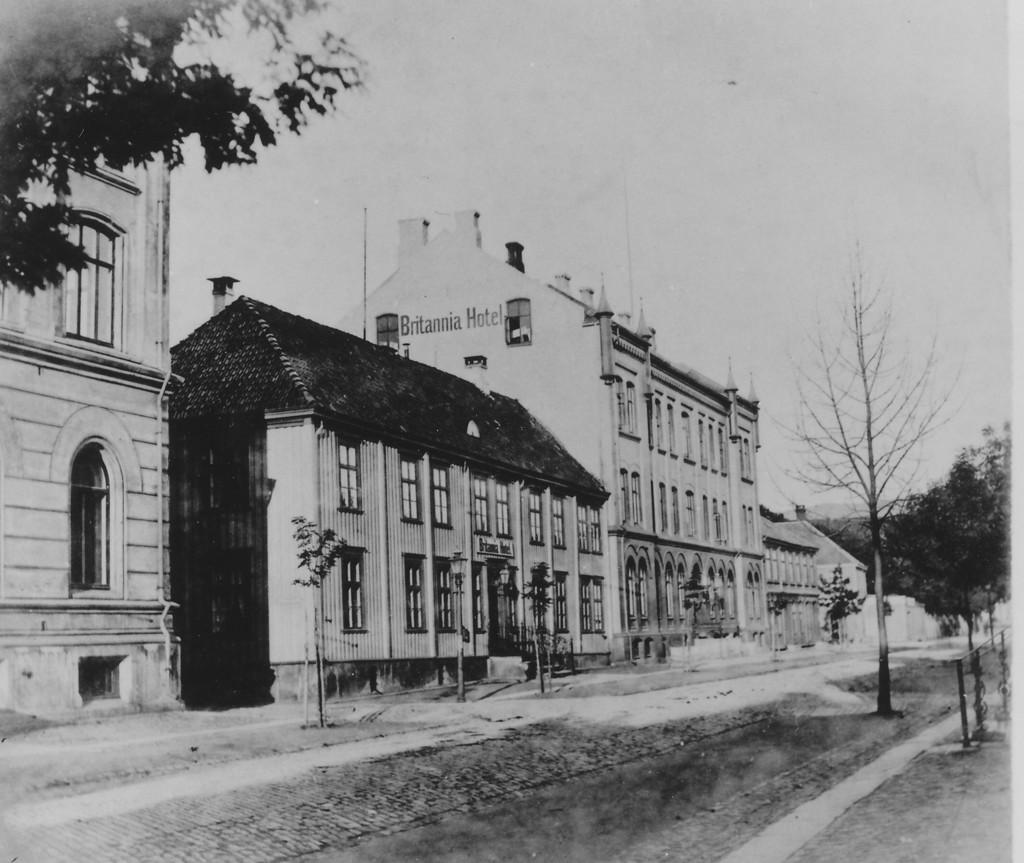What type of structures can be seen in the image? There are buildings in the image. What natural elements are present in the image? There are trees in the image. What other objects can be seen in the image? There are poles in the image. What is the color scheme of the image? The image is in black and white. What type of farm can be seen in the image? There is no farm present in the image; it features buildings, trees, and poles in a black and white color scheme. How does friction affect the movement of the trees in the image? The image is a still photograph, so there is no movement of the trees or any indication of friction. 